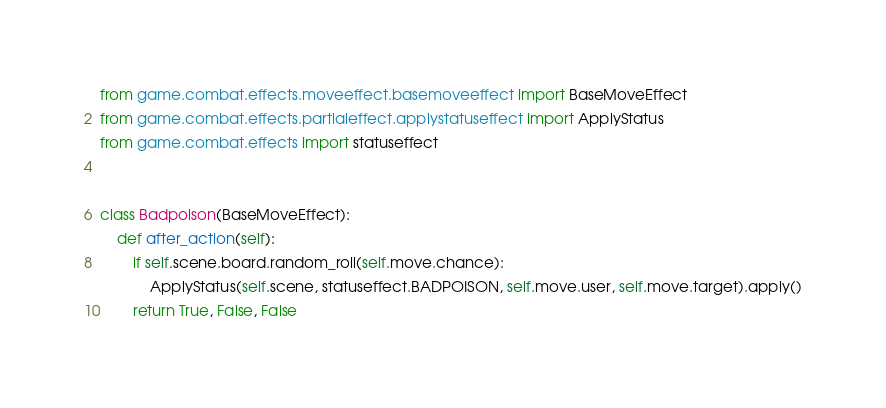<code> <loc_0><loc_0><loc_500><loc_500><_Python_>from game.combat.effects.moveeffect.basemoveeffect import BaseMoveEffect
from game.combat.effects.partialeffect.applystatuseffect import ApplyStatus
from game.combat.effects import statuseffect


class Badpoison(BaseMoveEffect):
    def after_action(self):
        if self.scene.board.random_roll(self.move.chance):
            ApplyStatus(self.scene, statuseffect.BADPOISON, self.move.user, self.move.target).apply()
        return True, False, False

</code> 